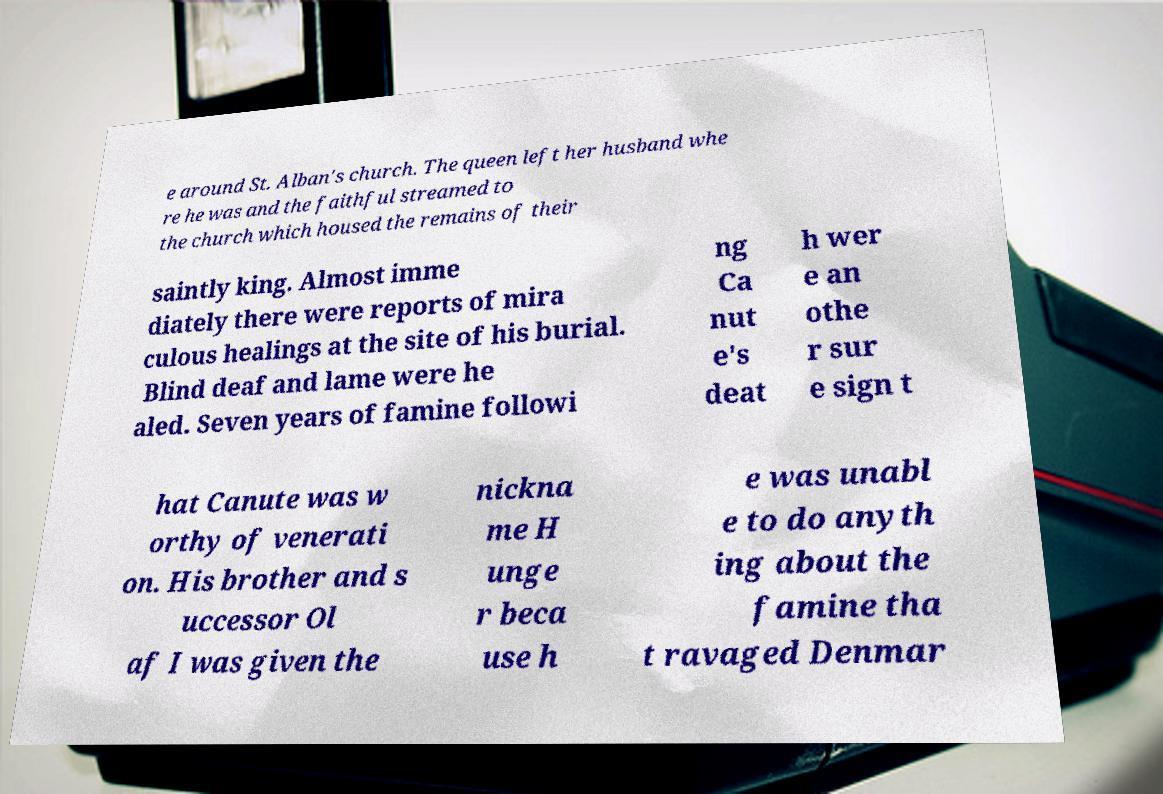Can you read and provide the text displayed in the image?This photo seems to have some interesting text. Can you extract and type it out for me? e around St. Alban's church. The queen left her husband whe re he was and the faithful streamed to the church which housed the remains of their saintly king. Almost imme diately there were reports of mira culous healings at the site of his burial. Blind deaf and lame were he aled. Seven years of famine followi ng Ca nut e's deat h wer e an othe r sur e sign t hat Canute was w orthy of venerati on. His brother and s uccessor Ol af I was given the nickna me H unge r beca use h e was unabl e to do anyth ing about the famine tha t ravaged Denmar 